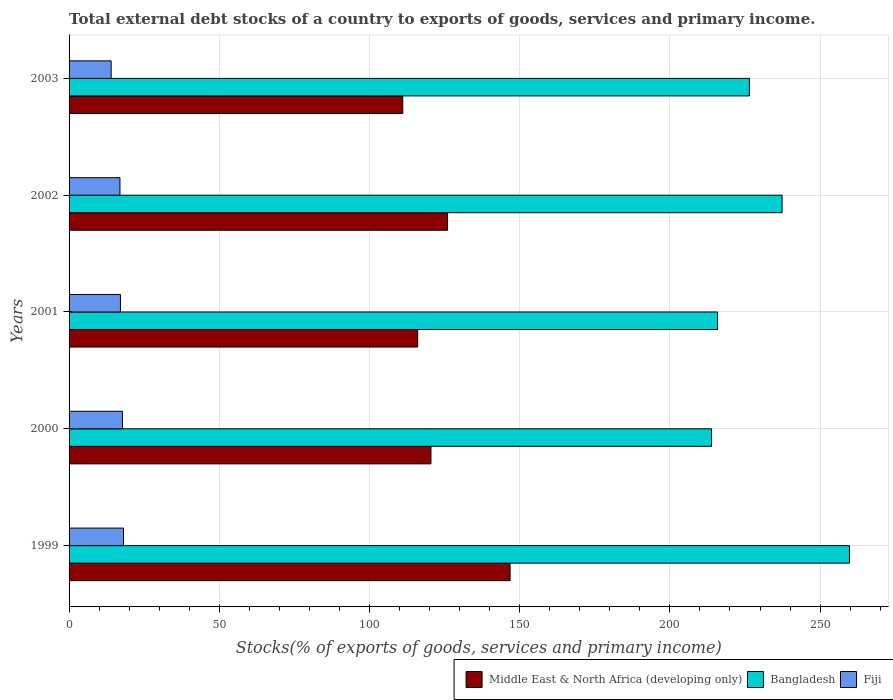How many different coloured bars are there?
Offer a terse response. 3. How many bars are there on the 2nd tick from the top?
Provide a short and direct response. 3. How many bars are there on the 5th tick from the bottom?
Give a very brief answer. 3. What is the total debt stocks in Fiji in 2001?
Offer a terse response. 17.1. Across all years, what is the maximum total debt stocks in Bangladesh?
Your answer should be very brief. 259.78. Across all years, what is the minimum total debt stocks in Fiji?
Your response must be concise. 14.01. What is the total total debt stocks in Bangladesh in the graph?
Provide a short and direct response. 1153.32. What is the difference between the total debt stocks in Bangladesh in 1999 and that in 2001?
Offer a very short reply. 43.91. What is the difference between the total debt stocks in Middle East & North Africa (developing only) in 2001 and the total debt stocks in Bangladesh in 2003?
Provide a short and direct response. -110.43. What is the average total debt stocks in Bangladesh per year?
Your response must be concise. 230.66. In the year 2000, what is the difference between the total debt stocks in Bangladesh and total debt stocks in Middle East & North Africa (developing only)?
Offer a very short reply. 93.4. What is the ratio of the total debt stocks in Middle East & North Africa (developing only) in 1999 to that in 2002?
Give a very brief answer. 1.17. What is the difference between the highest and the second highest total debt stocks in Fiji?
Offer a very short reply. 0.37. What is the difference between the highest and the lowest total debt stocks in Fiji?
Make the answer very short. 4.11. What does the 3rd bar from the top in 1999 represents?
Ensure brevity in your answer.  Middle East & North Africa (developing only). How many bars are there?
Your response must be concise. 15. What is the difference between two consecutive major ticks on the X-axis?
Your answer should be compact. 50. Does the graph contain grids?
Provide a short and direct response. Yes. How many legend labels are there?
Keep it short and to the point. 3. How are the legend labels stacked?
Your answer should be compact. Horizontal. What is the title of the graph?
Your answer should be very brief. Total external debt stocks of a country to exports of goods, services and primary income. Does "Caribbean small states" appear as one of the legend labels in the graph?
Make the answer very short. No. What is the label or title of the X-axis?
Offer a terse response. Stocks(% of exports of goods, services and primary income). What is the Stocks(% of exports of goods, services and primary income) of Middle East & North Africa (developing only) in 1999?
Offer a terse response. 146.81. What is the Stocks(% of exports of goods, services and primary income) in Bangladesh in 1999?
Give a very brief answer. 259.78. What is the Stocks(% of exports of goods, services and primary income) of Fiji in 1999?
Give a very brief answer. 18.12. What is the Stocks(% of exports of goods, services and primary income) in Middle East & North Africa (developing only) in 2000?
Your response must be concise. 120.47. What is the Stocks(% of exports of goods, services and primary income) of Bangladesh in 2000?
Offer a very short reply. 213.86. What is the Stocks(% of exports of goods, services and primary income) in Fiji in 2000?
Your answer should be compact. 17.75. What is the Stocks(% of exports of goods, services and primary income) in Middle East & North Africa (developing only) in 2001?
Give a very brief answer. 116.04. What is the Stocks(% of exports of goods, services and primary income) of Bangladesh in 2001?
Make the answer very short. 215.87. What is the Stocks(% of exports of goods, services and primary income) of Fiji in 2001?
Keep it short and to the point. 17.1. What is the Stocks(% of exports of goods, services and primary income) of Middle East & North Africa (developing only) in 2002?
Your answer should be compact. 125.99. What is the Stocks(% of exports of goods, services and primary income) of Bangladesh in 2002?
Provide a succinct answer. 237.35. What is the Stocks(% of exports of goods, services and primary income) in Fiji in 2002?
Your answer should be compact. 16.94. What is the Stocks(% of exports of goods, services and primary income) of Middle East & North Africa (developing only) in 2003?
Your answer should be compact. 111.08. What is the Stocks(% of exports of goods, services and primary income) in Bangladesh in 2003?
Your answer should be compact. 226.47. What is the Stocks(% of exports of goods, services and primary income) in Fiji in 2003?
Offer a terse response. 14.01. Across all years, what is the maximum Stocks(% of exports of goods, services and primary income) in Middle East & North Africa (developing only)?
Give a very brief answer. 146.81. Across all years, what is the maximum Stocks(% of exports of goods, services and primary income) of Bangladesh?
Your answer should be very brief. 259.78. Across all years, what is the maximum Stocks(% of exports of goods, services and primary income) of Fiji?
Provide a succinct answer. 18.12. Across all years, what is the minimum Stocks(% of exports of goods, services and primary income) in Middle East & North Africa (developing only)?
Ensure brevity in your answer.  111.08. Across all years, what is the minimum Stocks(% of exports of goods, services and primary income) of Bangladesh?
Ensure brevity in your answer.  213.86. Across all years, what is the minimum Stocks(% of exports of goods, services and primary income) of Fiji?
Your answer should be very brief. 14.01. What is the total Stocks(% of exports of goods, services and primary income) of Middle East & North Africa (developing only) in the graph?
Your answer should be compact. 620.38. What is the total Stocks(% of exports of goods, services and primary income) in Bangladesh in the graph?
Your answer should be very brief. 1153.32. What is the total Stocks(% of exports of goods, services and primary income) of Fiji in the graph?
Make the answer very short. 83.92. What is the difference between the Stocks(% of exports of goods, services and primary income) in Middle East & North Africa (developing only) in 1999 and that in 2000?
Offer a very short reply. 26.34. What is the difference between the Stocks(% of exports of goods, services and primary income) in Bangladesh in 1999 and that in 2000?
Provide a succinct answer. 45.92. What is the difference between the Stocks(% of exports of goods, services and primary income) in Fiji in 1999 and that in 2000?
Offer a very short reply. 0.37. What is the difference between the Stocks(% of exports of goods, services and primary income) in Middle East & North Africa (developing only) in 1999 and that in 2001?
Your answer should be compact. 30.77. What is the difference between the Stocks(% of exports of goods, services and primary income) in Bangladesh in 1999 and that in 2001?
Your response must be concise. 43.91. What is the difference between the Stocks(% of exports of goods, services and primary income) in Fiji in 1999 and that in 2001?
Your answer should be very brief. 1.02. What is the difference between the Stocks(% of exports of goods, services and primary income) in Middle East & North Africa (developing only) in 1999 and that in 2002?
Make the answer very short. 20.82. What is the difference between the Stocks(% of exports of goods, services and primary income) in Bangladesh in 1999 and that in 2002?
Offer a very short reply. 22.43. What is the difference between the Stocks(% of exports of goods, services and primary income) in Fiji in 1999 and that in 2002?
Provide a short and direct response. 1.18. What is the difference between the Stocks(% of exports of goods, services and primary income) in Middle East & North Africa (developing only) in 1999 and that in 2003?
Your response must be concise. 35.73. What is the difference between the Stocks(% of exports of goods, services and primary income) of Bangladesh in 1999 and that in 2003?
Your answer should be very brief. 33.31. What is the difference between the Stocks(% of exports of goods, services and primary income) of Fiji in 1999 and that in 2003?
Give a very brief answer. 4.11. What is the difference between the Stocks(% of exports of goods, services and primary income) in Middle East & North Africa (developing only) in 2000 and that in 2001?
Make the answer very short. 4.43. What is the difference between the Stocks(% of exports of goods, services and primary income) in Bangladesh in 2000 and that in 2001?
Give a very brief answer. -2.01. What is the difference between the Stocks(% of exports of goods, services and primary income) in Fiji in 2000 and that in 2001?
Provide a short and direct response. 0.65. What is the difference between the Stocks(% of exports of goods, services and primary income) in Middle East & North Africa (developing only) in 2000 and that in 2002?
Your answer should be very brief. -5.53. What is the difference between the Stocks(% of exports of goods, services and primary income) in Bangladesh in 2000 and that in 2002?
Provide a succinct answer. -23.49. What is the difference between the Stocks(% of exports of goods, services and primary income) of Fiji in 2000 and that in 2002?
Provide a short and direct response. 0.82. What is the difference between the Stocks(% of exports of goods, services and primary income) in Middle East & North Africa (developing only) in 2000 and that in 2003?
Offer a very short reply. 9.39. What is the difference between the Stocks(% of exports of goods, services and primary income) in Bangladesh in 2000 and that in 2003?
Offer a very short reply. -12.61. What is the difference between the Stocks(% of exports of goods, services and primary income) of Fiji in 2000 and that in 2003?
Your response must be concise. 3.75. What is the difference between the Stocks(% of exports of goods, services and primary income) of Middle East & North Africa (developing only) in 2001 and that in 2002?
Make the answer very short. -9.95. What is the difference between the Stocks(% of exports of goods, services and primary income) of Bangladesh in 2001 and that in 2002?
Your response must be concise. -21.48. What is the difference between the Stocks(% of exports of goods, services and primary income) of Fiji in 2001 and that in 2002?
Your response must be concise. 0.16. What is the difference between the Stocks(% of exports of goods, services and primary income) of Middle East & North Africa (developing only) in 2001 and that in 2003?
Offer a terse response. 4.96. What is the difference between the Stocks(% of exports of goods, services and primary income) in Bangladesh in 2001 and that in 2003?
Your answer should be compact. -10.6. What is the difference between the Stocks(% of exports of goods, services and primary income) in Fiji in 2001 and that in 2003?
Offer a terse response. 3.09. What is the difference between the Stocks(% of exports of goods, services and primary income) of Middle East & North Africa (developing only) in 2002 and that in 2003?
Keep it short and to the point. 14.91. What is the difference between the Stocks(% of exports of goods, services and primary income) in Bangladesh in 2002 and that in 2003?
Provide a short and direct response. 10.88. What is the difference between the Stocks(% of exports of goods, services and primary income) in Fiji in 2002 and that in 2003?
Offer a terse response. 2.93. What is the difference between the Stocks(% of exports of goods, services and primary income) of Middle East & North Africa (developing only) in 1999 and the Stocks(% of exports of goods, services and primary income) of Bangladesh in 2000?
Your answer should be very brief. -67.05. What is the difference between the Stocks(% of exports of goods, services and primary income) of Middle East & North Africa (developing only) in 1999 and the Stocks(% of exports of goods, services and primary income) of Fiji in 2000?
Provide a short and direct response. 129.05. What is the difference between the Stocks(% of exports of goods, services and primary income) in Bangladesh in 1999 and the Stocks(% of exports of goods, services and primary income) in Fiji in 2000?
Offer a terse response. 242.02. What is the difference between the Stocks(% of exports of goods, services and primary income) in Middle East & North Africa (developing only) in 1999 and the Stocks(% of exports of goods, services and primary income) in Bangladesh in 2001?
Provide a short and direct response. -69.06. What is the difference between the Stocks(% of exports of goods, services and primary income) in Middle East & North Africa (developing only) in 1999 and the Stocks(% of exports of goods, services and primary income) in Fiji in 2001?
Offer a very short reply. 129.71. What is the difference between the Stocks(% of exports of goods, services and primary income) of Bangladesh in 1999 and the Stocks(% of exports of goods, services and primary income) of Fiji in 2001?
Make the answer very short. 242.68. What is the difference between the Stocks(% of exports of goods, services and primary income) in Middle East & North Africa (developing only) in 1999 and the Stocks(% of exports of goods, services and primary income) in Bangladesh in 2002?
Your answer should be compact. -90.54. What is the difference between the Stocks(% of exports of goods, services and primary income) in Middle East & North Africa (developing only) in 1999 and the Stocks(% of exports of goods, services and primary income) in Fiji in 2002?
Your response must be concise. 129.87. What is the difference between the Stocks(% of exports of goods, services and primary income) in Bangladesh in 1999 and the Stocks(% of exports of goods, services and primary income) in Fiji in 2002?
Offer a very short reply. 242.84. What is the difference between the Stocks(% of exports of goods, services and primary income) in Middle East & North Africa (developing only) in 1999 and the Stocks(% of exports of goods, services and primary income) in Bangladesh in 2003?
Provide a succinct answer. -79.66. What is the difference between the Stocks(% of exports of goods, services and primary income) of Middle East & North Africa (developing only) in 1999 and the Stocks(% of exports of goods, services and primary income) of Fiji in 2003?
Your answer should be very brief. 132.8. What is the difference between the Stocks(% of exports of goods, services and primary income) of Bangladesh in 1999 and the Stocks(% of exports of goods, services and primary income) of Fiji in 2003?
Give a very brief answer. 245.77. What is the difference between the Stocks(% of exports of goods, services and primary income) in Middle East & North Africa (developing only) in 2000 and the Stocks(% of exports of goods, services and primary income) in Bangladesh in 2001?
Your answer should be compact. -95.4. What is the difference between the Stocks(% of exports of goods, services and primary income) in Middle East & North Africa (developing only) in 2000 and the Stocks(% of exports of goods, services and primary income) in Fiji in 2001?
Your answer should be compact. 103.36. What is the difference between the Stocks(% of exports of goods, services and primary income) in Bangladesh in 2000 and the Stocks(% of exports of goods, services and primary income) in Fiji in 2001?
Give a very brief answer. 196.76. What is the difference between the Stocks(% of exports of goods, services and primary income) in Middle East & North Africa (developing only) in 2000 and the Stocks(% of exports of goods, services and primary income) in Bangladesh in 2002?
Make the answer very short. -116.88. What is the difference between the Stocks(% of exports of goods, services and primary income) of Middle East & North Africa (developing only) in 2000 and the Stocks(% of exports of goods, services and primary income) of Fiji in 2002?
Offer a terse response. 103.53. What is the difference between the Stocks(% of exports of goods, services and primary income) of Bangladesh in 2000 and the Stocks(% of exports of goods, services and primary income) of Fiji in 2002?
Offer a very short reply. 196.92. What is the difference between the Stocks(% of exports of goods, services and primary income) in Middle East & North Africa (developing only) in 2000 and the Stocks(% of exports of goods, services and primary income) in Bangladesh in 2003?
Your answer should be compact. -106. What is the difference between the Stocks(% of exports of goods, services and primary income) of Middle East & North Africa (developing only) in 2000 and the Stocks(% of exports of goods, services and primary income) of Fiji in 2003?
Your answer should be compact. 106.46. What is the difference between the Stocks(% of exports of goods, services and primary income) in Bangladesh in 2000 and the Stocks(% of exports of goods, services and primary income) in Fiji in 2003?
Ensure brevity in your answer.  199.85. What is the difference between the Stocks(% of exports of goods, services and primary income) in Middle East & North Africa (developing only) in 2001 and the Stocks(% of exports of goods, services and primary income) in Bangladesh in 2002?
Give a very brief answer. -121.31. What is the difference between the Stocks(% of exports of goods, services and primary income) in Middle East & North Africa (developing only) in 2001 and the Stocks(% of exports of goods, services and primary income) in Fiji in 2002?
Your answer should be compact. 99.1. What is the difference between the Stocks(% of exports of goods, services and primary income) in Bangladesh in 2001 and the Stocks(% of exports of goods, services and primary income) in Fiji in 2002?
Your answer should be very brief. 198.93. What is the difference between the Stocks(% of exports of goods, services and primary income) of Middle East & North Africa (developing only) in 2001 and the Stocks(% of exports of goods, services and primary income) of Bangladesh in 2003?
Offer a terse response. -110.43. What is the difference between the Stocks(% of exports of goods, services and primary income) in Middle East & North Africa (developing only) in 2001 and the Stocks(% of exports of goods, services and primary income) in Fiji in 2003?
Your answer should be compact. 102.03. What is the difference between the Stocks(% of exports of goods, services and primary income) of Bangladesh in 2001 and the Stocks(% of exports of goods, services and primary income) of Fiji in 2003?
Keep it short and to the point. 201.86. What is the difference between the Stocks(% of exports of goods, services and primary income) of Middle East & North Africa (developing only) in 2002 and the Stocks(% of exports of goods, services and primary income) of Bangladesh in 2003?
Provide a succinct answer. -100.48. What is the difference between the Stocks(% of exports of goods, services and primary income) in Middle East & North Africa (developing only) in 2002 and the Stocks(% of exports of goods, services and primary income) in Fiji in 2003?
Your answer should be very brief. 111.98. What is the difference between the Stocks(% of exports of goods, services and primary income) in Bangladesh in 2002 and the Stocks(% of exports of goods, services and primary income) in Fiji in 2003?
Offer a very short reply. 223.34. What is the average Stocks(% of exports of goods, services and primary income) in Middle East & North Africa (developing only) per year?
Provide a succinct answer. 124.08. What is the average Stocks(% of exports of goods, services and primary income) of Bangladesh per year?
Your answer should be very brief. 230.66. What is the average Stocks(% of exports of goods, services and primary income) of Fiji per year?
Make the answer very short. 16.78. In the year 1999, what is the difference between the Stocks(% of exports of goods, services and primary income) in Middle East & North Africa (developing only) and Stocks(% of exports of goods, services and primary income) in Bangladesh?
Your answer should be very brief. -112.97. In the year 1999, what is the difference between the Stocks(% of exports of goods, services and primary income) in Middle East & North Africa (developing only) and Stocks(% of exports of goods, services and primary income) in Fiji?
Provide a succinct answer. 128.69. In the year 1999, what is the difference between the Stocks(% of exports of goods, services and primary income) in Bangladesh and Stocks(% of exports of goods, services and primary income) in Fiji?
Your response must be concise. 241.66. In the year 2000, what is the difference between the Stocks(% of exports of goods, services and primary income) of Middle East & North Africa (developing only) and Stocks(% of exports of goods, services and primary income) of Bangladesh?
Your response must be concise. -93.4. In the year 2000, what is the difference between the Stocks(% of exports of goods, services and primary income) of Middle East & North Africa (developing only) and Stocks(% of exports of goods, services and primary income) of Fiji?
Ensure brevity in your answer.  102.71. In the year 2000, what is the difference between the Stocks(% of exports of goods, services and primary income) of Bangladesh and Stocks(% of exports of goods, services and primary income) of Fiji?
Provide a short and direct response. 196.11. In the year 2001, what is the difference between the Stocks(% of exports of goods, services and primary income) in Middle East & North Africa (developing only) and Stocks(% of exports of goods, services and primary income) in Bangladesh?
Your response must be concise. -99.83. In the year 2001, what is the difference between the Stocks(% of exports of goods, services and primary income) in Middle East & North Africa (developing only) and Stocks(% of exports of goods, services and primary income) in Fiji?
Make the answer very short. 98.94. In the year 2001, what is the difference between the Stocks(% of exports of goods, services and primary income) of Bangladesh and Stocks(% of exports of goods, services and primary income) of Fiji?
Your answer should be compact. 198.77. In the year 2002, what is the difference between the Stocks(% of exports of goods, services and primary income) of Middle East & North Africa (developing only) and Stocks(% of exports of goods, services and primary income) of Bangladesh?
Your response must be concise. -111.36. In the year 2002, what is the difference between the Stocks(% of exports of goods, services and primary income) in Middle East & North Africa (developing only) and Stocks(% of exports of goods, services and primary income) in Fiji?
Your answer should be very brief. 109.05. In the year 2002, what is the difference between the Stocks(% of exports of goods, services and primary income) in Bangladesh and Stocks(% of exports of goods, services and primary income) in Fiji?
Your answer should be very brief. 220.41. In the year 2003, what is the difference between the Stocks(% of exports of goods, services and primary income) in Middle East & North Africa (developing only) and Stocks(% of exports of goods, services and primary income) in Bangladesh?
Your response must be concise. -115.39. In the year 2003, what is the difference between the Stocks(% of exports of goods, services and primary income) in Middle East & North Africa (developing only) and Stocks(% of exports of goods, services and primary income) in Fiji?
Offer a terse response. 97.07. In the year 2003, what is the difference between the Stocks(% of exports of goods, services and primary income) of Bangladesh and Stocks(% of exports of goods, services and primary income) of Fiji?
Make the answer very short. 212.46. What is the ratio of the Stocks(% of exports of goods, services and primary income) of Middle East & North Africa (developing only) in 1999 to that in 2000?
Ensure brevity in your answer.  1.22. What is the ratio of the Stocks(% of exports of goods, services and primary income) in Bangladesh in 1999 to that in 2000?
Provide a succinct answer. 1.21. What is the ratio of the Stocks(% of exports of goods, services and primary income) in Fiji in 1999 to that in 2000?
Offer a very short reply. 1.02. What is the ratio of the Stocks(% of exports of goods, services and primary income) of Middle East & North Africa (developing only) in 1999 to that in 2001?
Provide a succinct answer. 1.27. What is the ratio of the Stocks(% of exports of goods, services and primary income) of Bangladesh in 1999 to that in 2001?
Provide a short and direct response. 1.2. What is the ratio of the Stocks(% of exports of goods, services and primary income) of Fiji in 1999 to that in 2001?
Your answer should be very brief. 1.06. What is the ratio of the Stocks(% of exports of goods, services and primary income) of Middle East & North Africa (developing only) in 1999 to that in 2002?
Your answer should be very brief. 1.17. What is the ratio of the Stocks(% of exports of goods, services and primary income) in Bangladesh in 1999 to that in 2002?
Offer a terse response. 1.09. What is the ratio of the Stocks(% of exports of goods, services and primary income) in Fiji in 1999 to that in 2002?
Your response must be concise. 1.07. What is the ratio of the Stocks(% of exports of goods, services and primary income) in Middle East & North Africa (developing only) in 1999 to that in 2003?
Give a very brief answer. 1.32. What is the ratio of the Stocks(% of exports of goods, services and primary income) of Bangladesh in 1999 to that in 2003?
Give a very brief answer. 1.15. What is the ratio of the Stocks(% of exports of goods, services and primary income) of Fiji in 1999 to that in 2003?
Keep it short and to the point. 1.29. What is the ratio of the Stocks(% of exports of goods, services and primary income) of Middle East & North Africa (developing only) in 2000 to that in 2001?
Ensure brevity in your answer.  1.04. What is the ratio of the Stocks(% of exports of goods, services and primary income) of Bangladesh in 2000 to that in 2001?
Offer a terse response. 0.99. What is the ratio of the Stocks(% of exports of goods, services and primary income) in Fiji in 2000 to that in 2001?
Offer a terse response. 1.04. What is the ratio of the Stocks(% of exports of goods, services and primary income) in Middle East & North Africa (developing only) in 2000 to that in 2002?
Provide a succinct answer. 0.96. What is the ratio of the Stocks(% of exports of goods, services and primary income) in Bangladesh in 2000 to that in 2002?
Offer a very short reply. 0.9. What is the ratio of the Stocks(% of exports of goods, services and primary income) of Fiji in 2000 to that in 2002?
Ensure brevity in your answer.  1.05. What is the ratio of the Stocks(% of exports of goods, services and primary income) of Middle East & North Africa (developing only) in 2000 to that in 2003?
Your answer should be very brief. 1.08. What is the ratio of the Stocks(% of exports of goods, services and primary income) of Bangladesh in 2000 to that in 2003?
Keep it short and to the point. 0.94. What is the ratio of the Stocks(% of exports of goods, services and primary income) of Fiji in 2000 to that in 2003?
Offer a very short reply. 1.27. What is the ratio of the Stocks(% of exports of goods, services and primary income) in Middle East & North Africa (developing only) in 2001 to that in 2002?
Offer a very short reply. 0.92. What is the ratio of the Stocks(% of exports of goods, services and primary income) of Bangladesh in 2001 to that in 2002?
Give a very brief answer. 0.91. What is the ratio of the Stocks(% of exports of goods, services and primary income) of Fiji in 2001 to that in 2002?
Provide a succinct answer. 1.01. What is the ratio of the Stocks(% of exports of goods, services and primary income) of Middle East & North Africa (developing only) in 2001 to that in 2003?
Provide a succinct answer. 1.04. What is the ratio of the Stocks(% of exports of goods, services and primary income) of Bangladesh in 2001 to that in 2003?
Offer a very short reply. 0.95. What is the ratio of the Stocks(% of exports of goods, services and primary income) in Fiji in 2001 to that in 2003?
Provide a succinct answer. 1.22. What is the ratio of the Stocks(% of exports of goods, services and primary income) of Middle East & North Africa (developing only) in 2002 to that in 2003?
Give a very brief answer. 1.13. What is the ratio of the Stocks(% of exports of goods, services and primary income) in Bangladesh in 2002 to that in 2003?
Offer a terse response. 1.05. What is the ratio of the Stocks(% of exports of goods, services and primary income) of Fiji in 2002 to that in 2003?
Provide a short and direct response. 1.21. What is the difference between the highest and the second highest Stocks(% of exports of goods, services and primary income) in Middle East & North Africa (developing only)?
Offer a very short reply. 20.82. What is the difference between the highest and the second highest Stocks(% of exports of goods, services and primary income) in Bangladesh?
Your answer should be compact. 22.43. What is the difference between the highest and the second highest Stocks(% of exports of goods, services and primary income) in Fiji?
Your answer should be very brief. 0.37. What is the difference between the highest and the lowest Stocks(% of exports of goods, services and primary income) of Middle East & North Africa (developing only)?
Your answer should be compact. 35.73. What is the difference between the highest and the lowest Stocks(% of exports of goods, services and primary income) in Bangladesh?
Your response must be concise. 45.92. What is the difference between the highest and the lowest Stocks(% of exports of goods, services and primary income) of Fiji?
Keep it short and to the point. 4.11. 